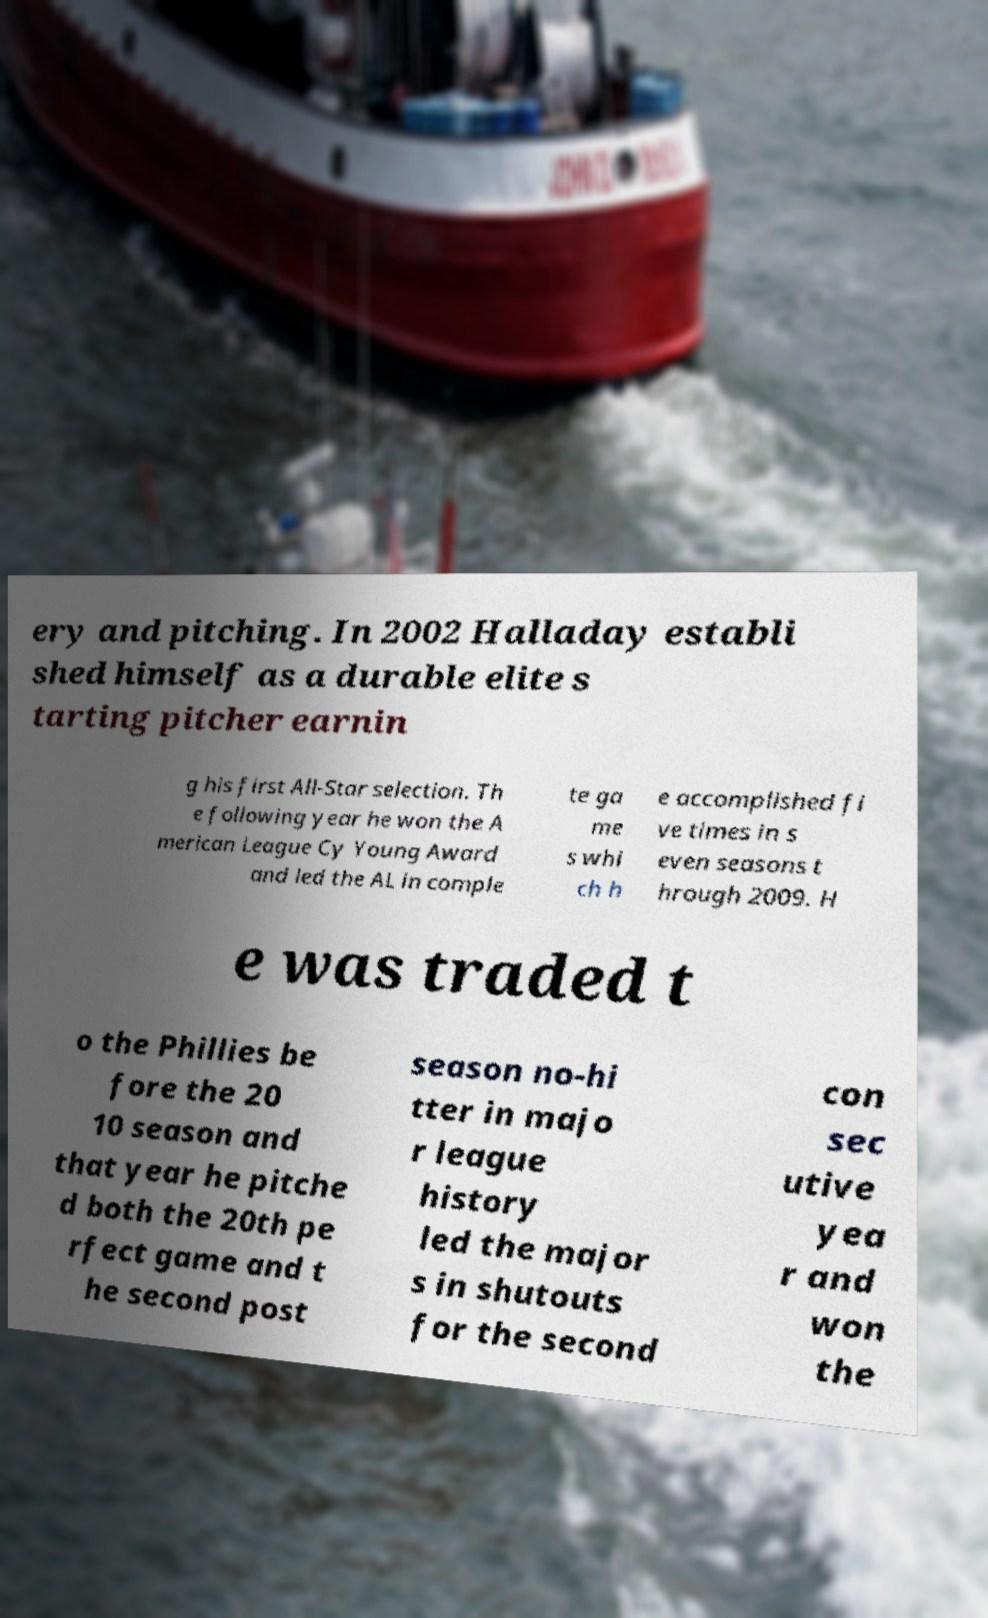Please identify and transcribe the text found in this image. ery and pitching. In 2002 Halladay establi shed himself as a durable elite s tarting pitcher earnin g his first All-Star selection. Th e following year he won the A merican League Cy Young Award and led the AL in comple te ga me s whi ch h e accomplished fi ve times in s even seasons t hrough 2009. H e was traded t o the Phillies be fore the 20 10 season and that year he pitche d both the 20th pe rfect game and t he second post season no-hi tter in majo r league history led the major s in shutouts for the second con sec utive yea r and won the 